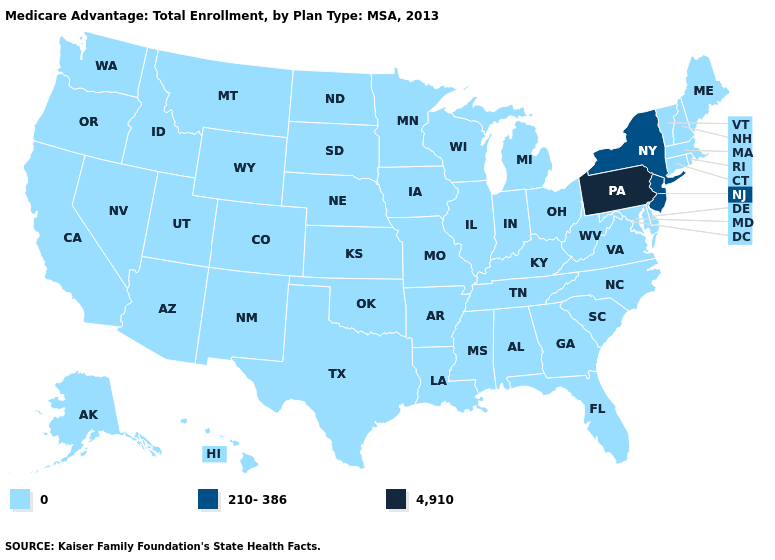What is the value of Mississippi?
Keep it brief. 0. Name the states that have a value in the range 4,910?
Write a very short answer. Pennsylvania. Name the states that have a value in the range 0?
Write a very short answer. Alaska, Alabama, Arkansas, Arizona, California, Colorado, Connecticut, Delaware, Florida, Georgia, Hawaii, Iowa, Idaho, Illinois, Indiana, Kansas, Kentucky, Louisiana, Massachusetts, Maryland, Maine, Michigan, Minnesota, Missouri, Mississippi, Montana, North Carolina, North Dakota, Nebraska, New Hampshire, New Mexico, Nevada, Ohio, Oklahoma, Oregon, Rhode Island, South Carolina, South Dakota, Tennessee, Texas, Utah, Virginia, Vermont, Washington, Wisconsin, West Virginia, Wyoming. Among the states that border Oklahoma , which have the lowest value?
Quick response, please. Arkansas, Colorado, Kansas, Missouri, New Mexico, Texas. Does Missouri have a lower value than Pennsylvania?
Answer briefly. Yes. What is the lowest value in the USA?
Quick response, please. 0. Name the states that have a value in the range 4,910?
Give a very brief answer. Pennsylvania. Does the map have missing data?
Keep it brief. No. Name the states that have a value in the range 4,910?
Give a very brief answer. Pennsylvania. Name the states that have a value in the range 4,910?
Give a very brief answer. Pennsylvania. What is the highest value in the MidWest ?
Short answer required. 0. What is the lowest value in the USA?
Write a very short answer. 0. What is the lowest value in states that border Vermont?
Keep it brief. 0. Name the states that have a value in the range 210-386?
Answer briefly. New Jersey, New York. 